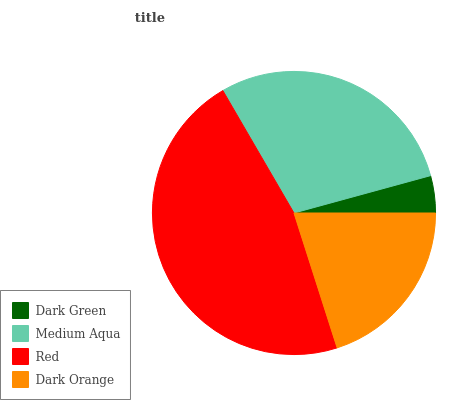Is Dark Green the minimum?
Answer yes or no. Yes. Is Red the maximum?
Answer yes or no. Yes. Is Medium Aqua the minimum?
Answer yes or no. No. Is Medium Aqua the maximum?
Answer yes or no. No. Is Medium Aqua greater than Dark Green?
Answer yes or no. Yes. Is Dark Green less than Medium Aqua?
Answer yes or no. Yes. Is Dark Green greater than Medium Aqua?
Answer yes or no. No. Is Medium Aqua less than Dark Green?
Answer yes or no. No. Is Medium Aqua the high median?
Answer yes or no. Yes. Is Dark Orange the low median?
Answer yes or no. Yes. Is Dark Orange the high median?
Answer yes or no. No. Is Medium Aqua the low median?
Answer yes or no. No. 